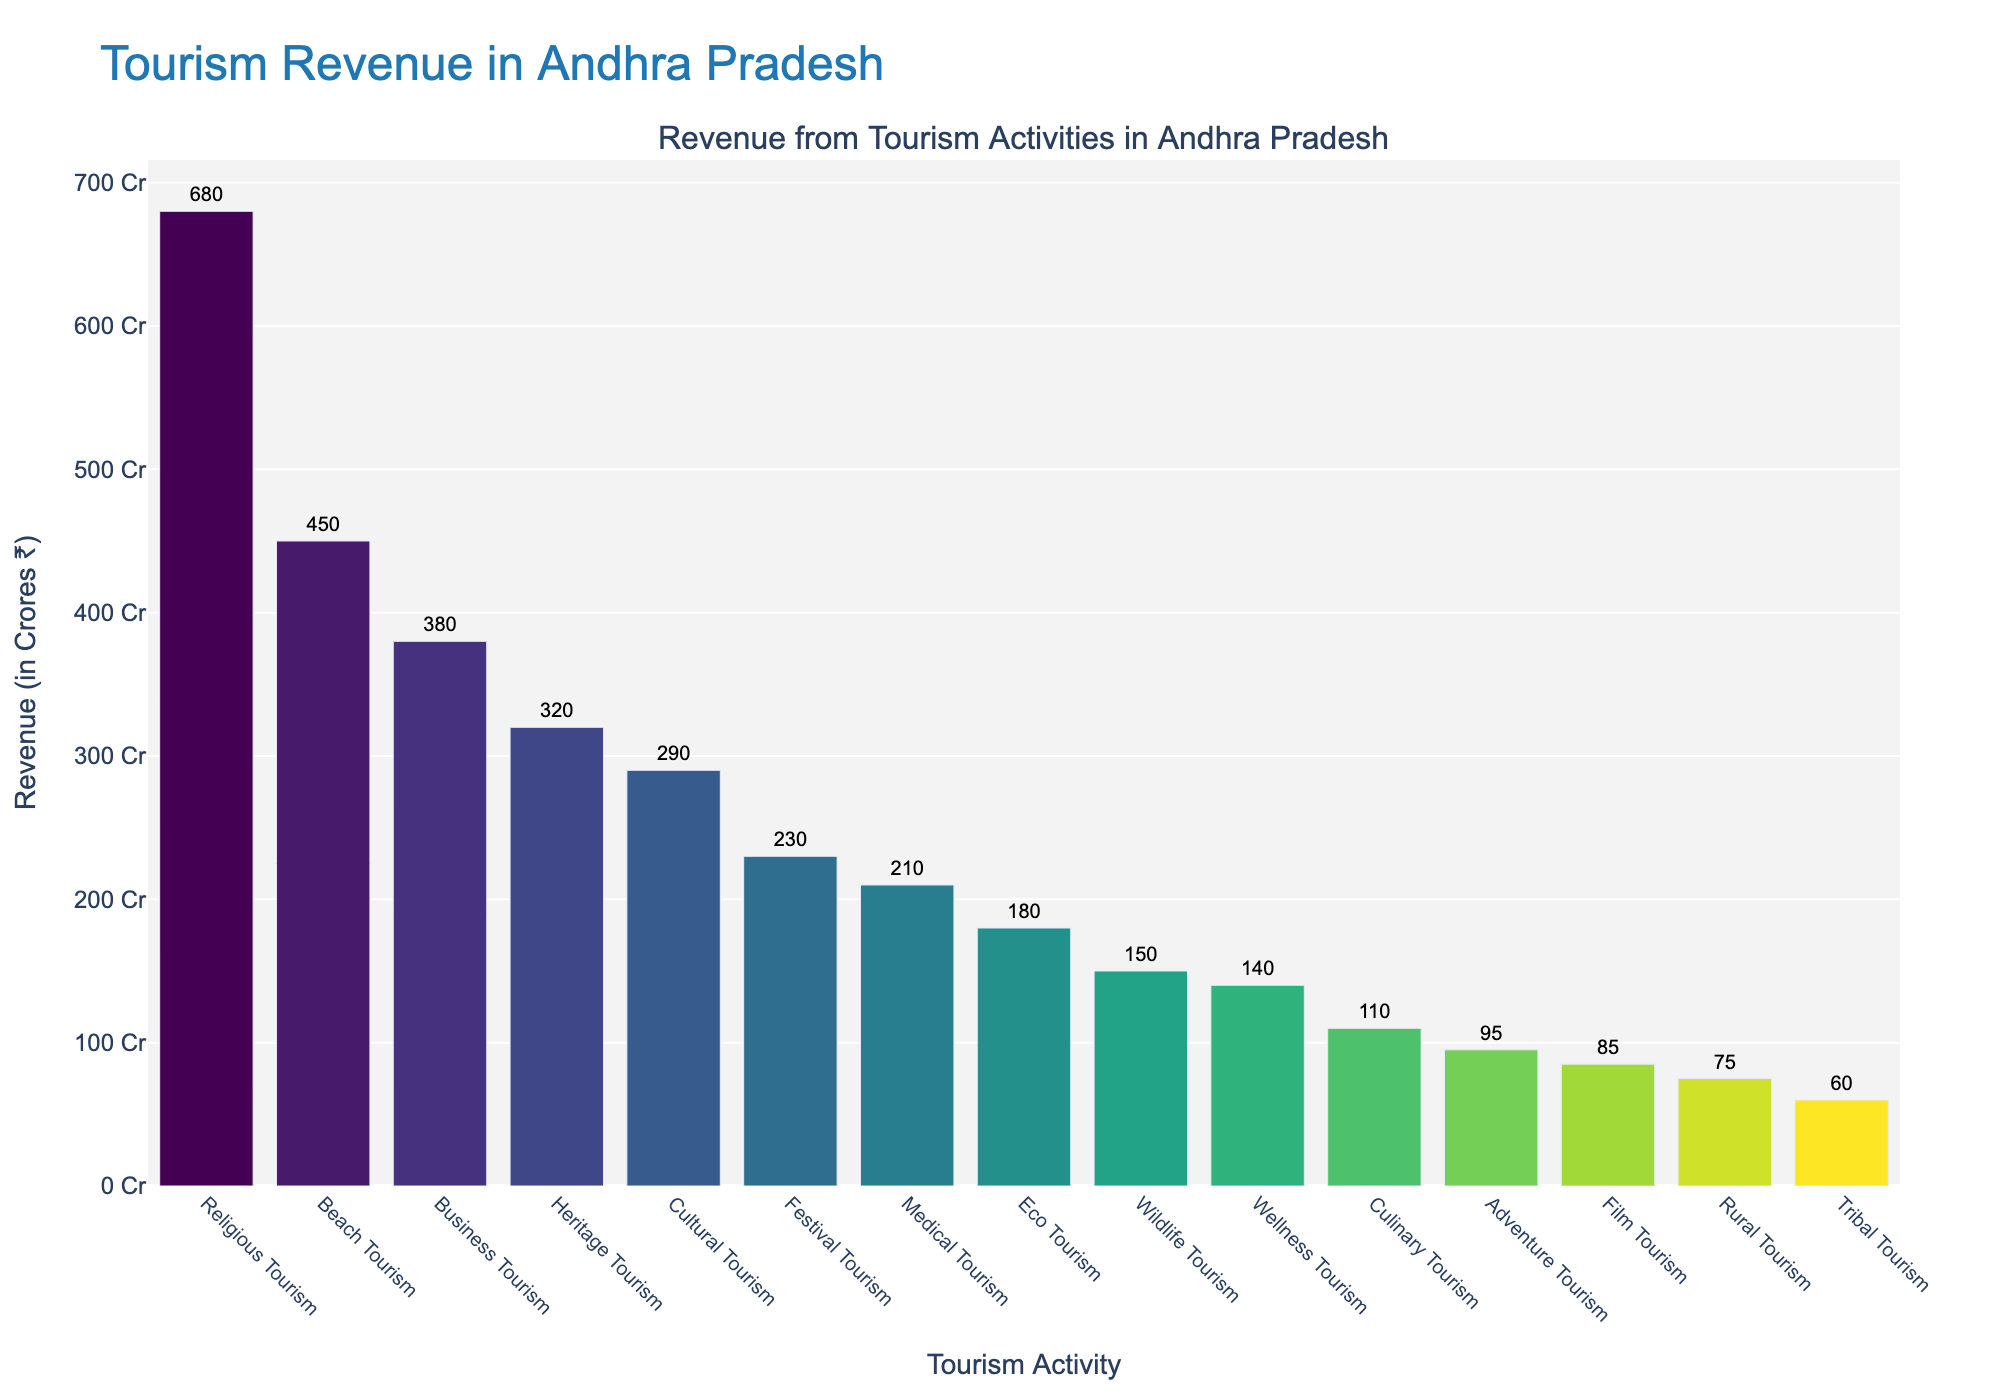Which tourism activity generates the highest revenue? The highest bar represents the tourism activity with the greatest revenue. Beach Tourism, with a height corresponding to 680 crores, is the highest.
Answer: Religious Tourism Which tourism activity generates the lowest revenue? The shortest bar corresponds to the tourism activity with the lowest revenue. Tribal Tourism, with a height corresponding to 60 crores, is the shortest bar.
Answer: Tribal Tourism What is the total revenue generated by Beach Tourism and Business Tourism combined? Locate the bars for Beach Tourism and Business Tourism, whose heights are 450 crores and 380 crores, respectively. Add these amounts together: 450 + 380 = 830 crores.
Answer: 830 crores How much more revenue does Religious Tourism generate compared to Heritage Tourism? Identify the bars for Religious Tourism (680 crores) and Heritage Tourism (320 crores). Calculate the difference: 680 - 320 = 360 crores.
Answer: 360 crores Among Cultural Tourism, Wildlife Tourism, and Wellness Tourism, which generates the highest revenue? Compare the heights of the three bars. Cultural Tourism (290 crores) is higher than Wildlife Tourism (150 crores) and Wellness Tourism (140 crores).
Answer: Cultural Tourism What is the average revenue generated from Eco Tourism, Adventure Tourism, and Culinary Tourism? Add the revenue values for Eco Tourism (180 crores), Adventure Tourism (95 crores), and Culinary Tourism (110 crores) then divide by 3: (180 + 95 + 110) / 3 = 385 / 3 = 128.33 crores.
Answer: 128.33 crores Is the revenue generated from Medical Tourism greater than the revenue generated from Film Tourism and Festival Tourism combined? Compare Medical Tourism (210 crores) with the sum of Film Tourism (85 crores) and Festival Tourism (230 crores). Add Film and Festival Tourism: 85 + 230 = 315 crores. Compare 210 crores to 315 crores to conclude it is not greater.
Answer: No What is the color pattern used in representing the tourism activities? The colors of the bars transition according to a 'Viridis' scale where color intensity changes from cool (blue-green) to warm (yellow-green) shades.
Answer: From cool (blue-green) to warm (yellow-green) Which tourism activity generates more revenue, Business Tourism or Cultural Tourism? Compare the heights of the bars for Business Tourism (380 crores) and Cultural Tourism (290 crores). Business Tourism generates more.
Answer: Business Tourism How much revenue is generated from the top three revenue-generating tourism activities combined? Identify the top three tourism activities: Religious Tourism (680 crores), Beach Tourism (450 crores), and Business Tourism (380 crores). Sum these values: 680 + 450 + 380 = 1510 crores.
Answer: 1510 crores 